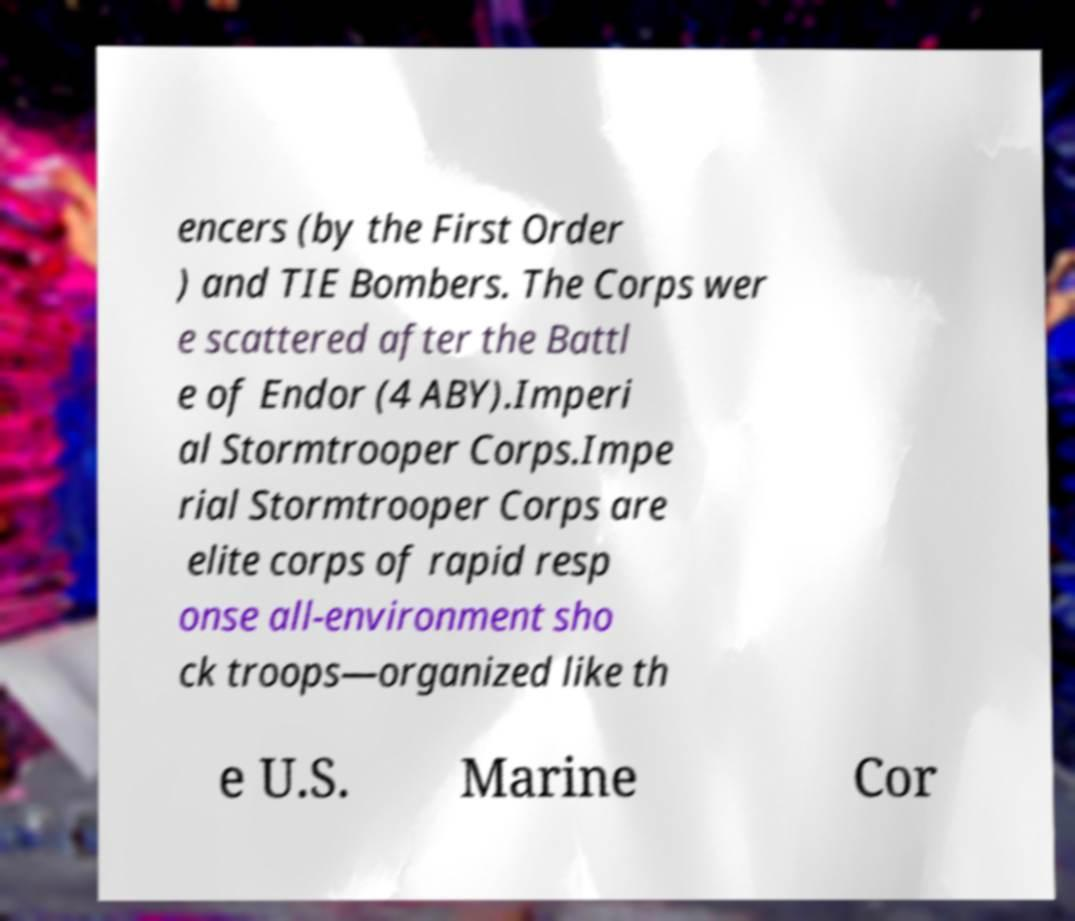Can you read and provide the text displayed in the image?This photo seems to have some interesting text. Can you extract and type it out for me? encers (by the First Order ) and TIE Bombers. The Corps wer e scattered after the Battl e of Endor (4 ABY).Imperi al Stormtrooper Corps.Impe rial Stormtrooper Corps are elite corps of rapid resp onse all-environment sho ck troops—organized like th e U.S. Marine Cor 